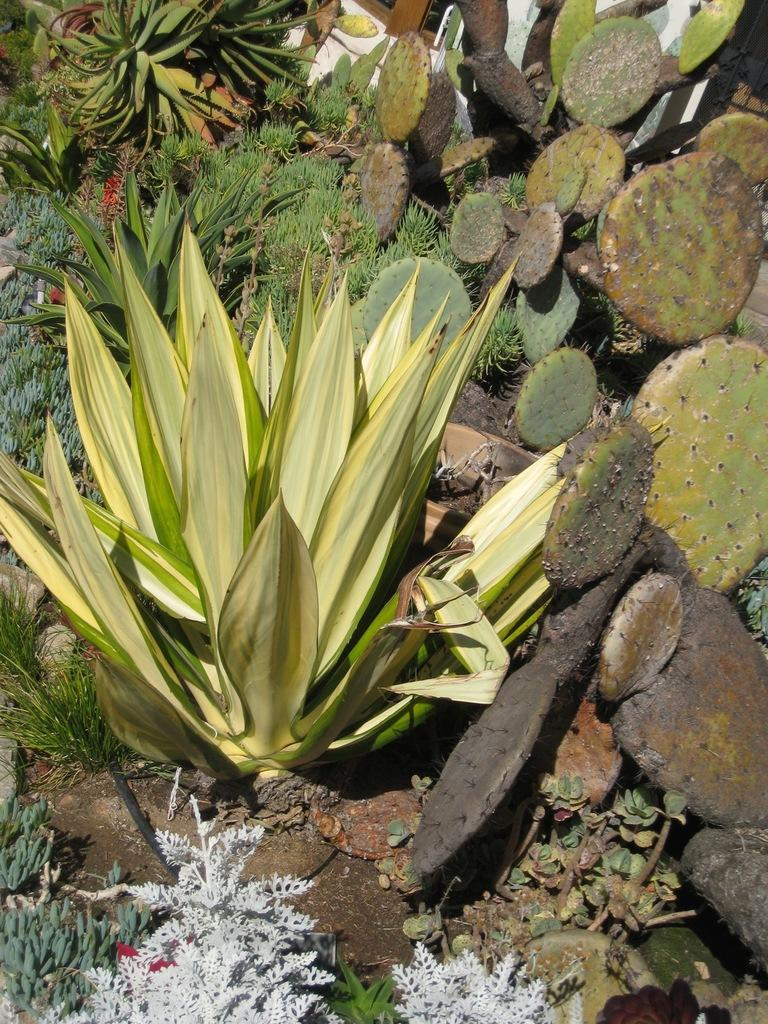What types of living organisms can be seen in the image? There are many plants in the image. What is visible at the bottom of the image? There is ground visible at the bottom of the image. What type of building can be seen in the image? There is no building present in the image; it features many plants and ground. How low are the plants in the image? The height of the plants cannot be determined from the image alone, as there is no reference point for comparison. 